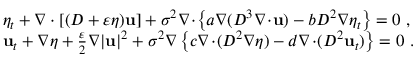<formula> <loc_0><loc_0><loc_500><loc_500>\begin{array} { r l } & { \eta _ { t } + \nabla \cdot [ ( D + \varepsilon \eta ) u ] + \sigma ^ { 2 } \nabla \, \cdot \, \left \{ a \nabla ( D ^ { 3 } \nabla \, \cdot \, u ) - b D ^ { 2 } \nabla \eta _ { t } \right \} = 0 \ , } \\ & { { u } _ { t } + \nabla \eta + \frac { \varepsilon } { 2 } \nabla | u | ^ { 2 } + \sigma ^ { 2 } \nabla \left \{ c \nabla \, \cdot \, ( D ^ { 2 } \nabla \eta ) - d \nabla \, \cdot \, ( D ^ { 2 } u _ { t } ) \right \} = 0 \ . } \end{array}</formula> 